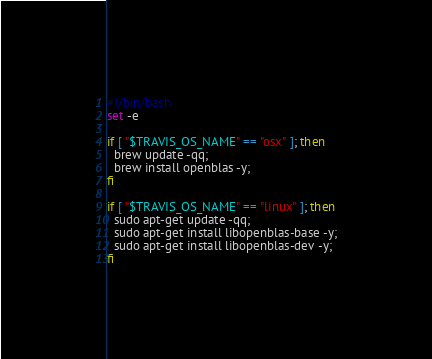Convert code to text. <code><loc_0><loc_0><loc_500><loc_500><_Bash_>#!/bin/bash
set -e

if [ "$TRAVIS_OS_NAME" == "osx" ]; then
  brew update -qq;
  brew install openblas -y;
fi

if [ "$TRAVIS_OS_NAME" == "linux" ]; then
  sudo apt-get update -qq;
  sudo apt-get install libopenblas-base -y;
  sudo apt-get install libopenblas-dev -y;
fi</code> 